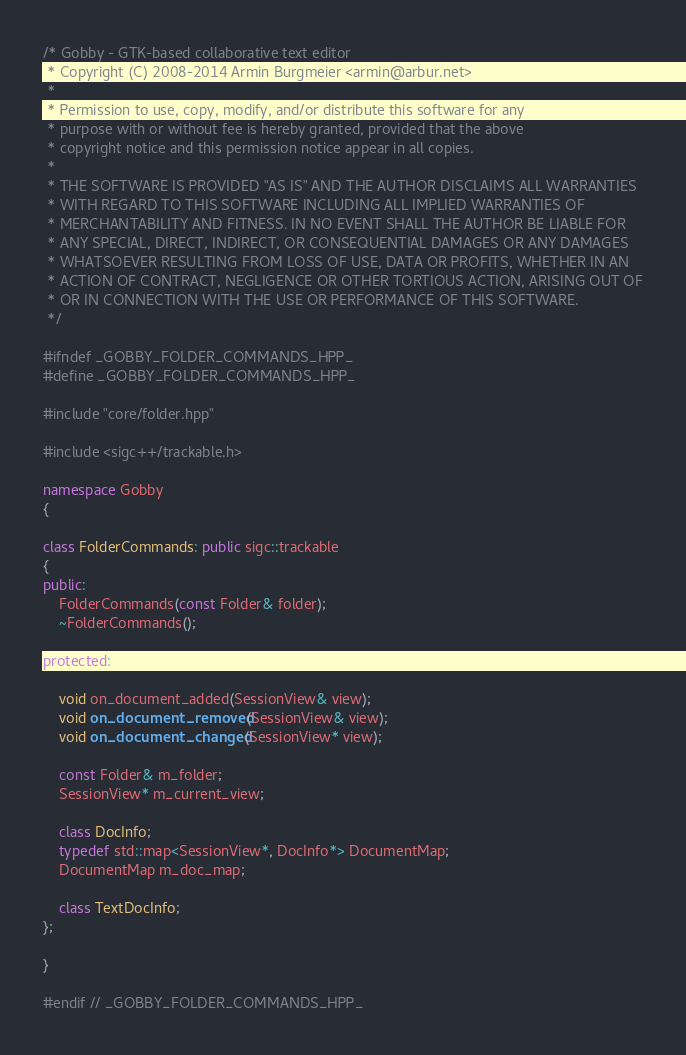<code> <loc_0><loc_0><loc_500><loc_500><_C++_>/* Gobby - GTK-based collaborative text editor
 * Copyright (C) 2008-2014 Armin Burgmeier <armin@arbur.net>
 *
 * Permission to use, copy, modify, and/or distribute this software for any
 * purpose with or without fee is hereby granted, provided that the above
 * copyright notice and this permission notice appear in all copies.
 *
 * THE SOFTWARE IS PROVIDED "AS IS" AND THE AUTHOR DISCLAIMS ALL WARRANTIES
 * WITH REGARD TO THIS SOFTWARE INCLUDING ALL IMPLIED WARRANTIES OF
 * MERCHANTABILITY AND FITNESS. IN NO EVENT SHALL THE AUTHOR BE LIABLE FOR
 * ANY SPECIAL, DIRECT, INDIRECT, OR CONSEQUENTIAL DAMAGES OR ANY DAMAGES
 * WHATSOEVER RESULTING FROM LOSS OF USE, DATA OR PROFITS, WHETHER IN AN
 * ACTION OF CONTRACT, NEGLIGENCE OR OTHER TORTIOUS ACTION, ARISING OUT OF
 * OR IN CONNECTION WITH THE USE OR PERFORMANCE OF THIS SOFTWARE.
 */

#ifndef _GOBBY_FOLDER_COMMANDS_HPP_
#define _GOBBY_FOLDER_COMMANDS_HPP_

#include "core/folder.hpp"

#include <sigc++/trackable.h>

namespace Gobby
{

class FolderCommands: public sigc::trackable
{
public:
	FolderCommands(const Folder& folder);
	~FolderCommands();

protected:

	void on_document_added(SessionView& view);
	void on_document_removed(SessionView& view);
	void on_document_changed(SessionView* view);

	const Folder& m_folder;
	SessionView* m_current_view;

	class DocInfo;
	typedef std::map<SessionView*, DocInfo*> DocumentMap;
	DocumentMap m_doc_map;

	class TextDocInfo;
};

}

#endif // _GOBBY_FOLDER_COMMANDS_HPP_
</code> 